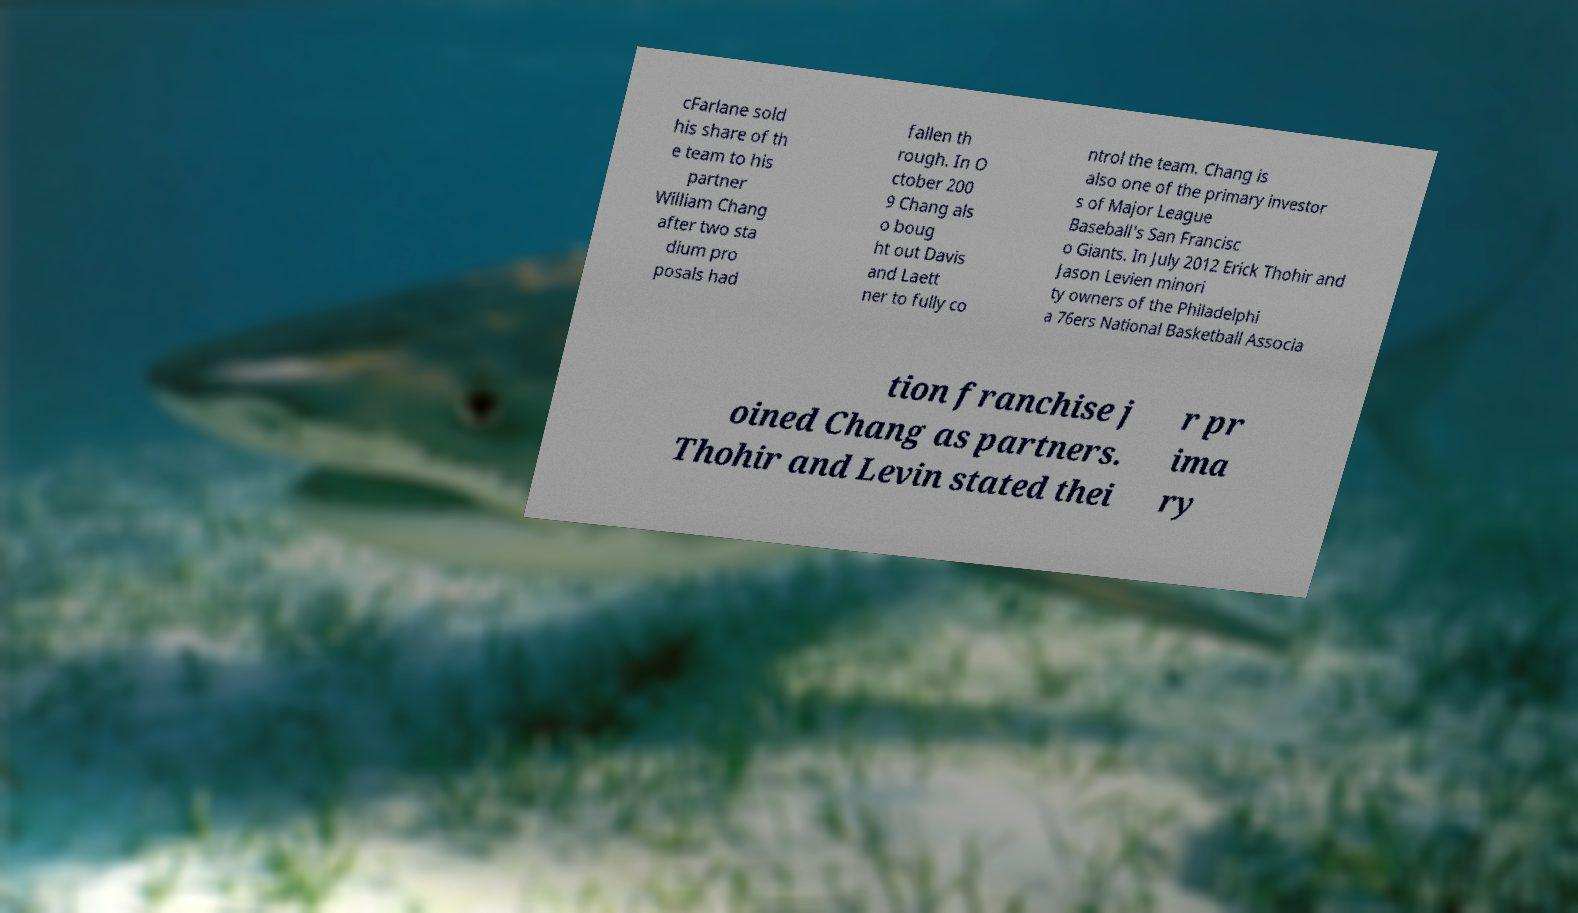Please read and relay the text visible in this image. What does it say? cFarlane sold his share of th e team to his partner William Chang after two sta dium pro posals had fallen th rough. In O ctober 200 9 Chang als o boug ht out Davis and Laett ner to fully co ntrol the team. Chang is also one of the primary investor s of Major League Baseball's San Francisc o Giants. In July 2012 Erick Thohir and Jason Levien minori ty owners of the Philadelphi a 76ers National Basketball Associa tion franchise j oined Chang as partners. Thohir and Levin stated thei r pr ima ry 